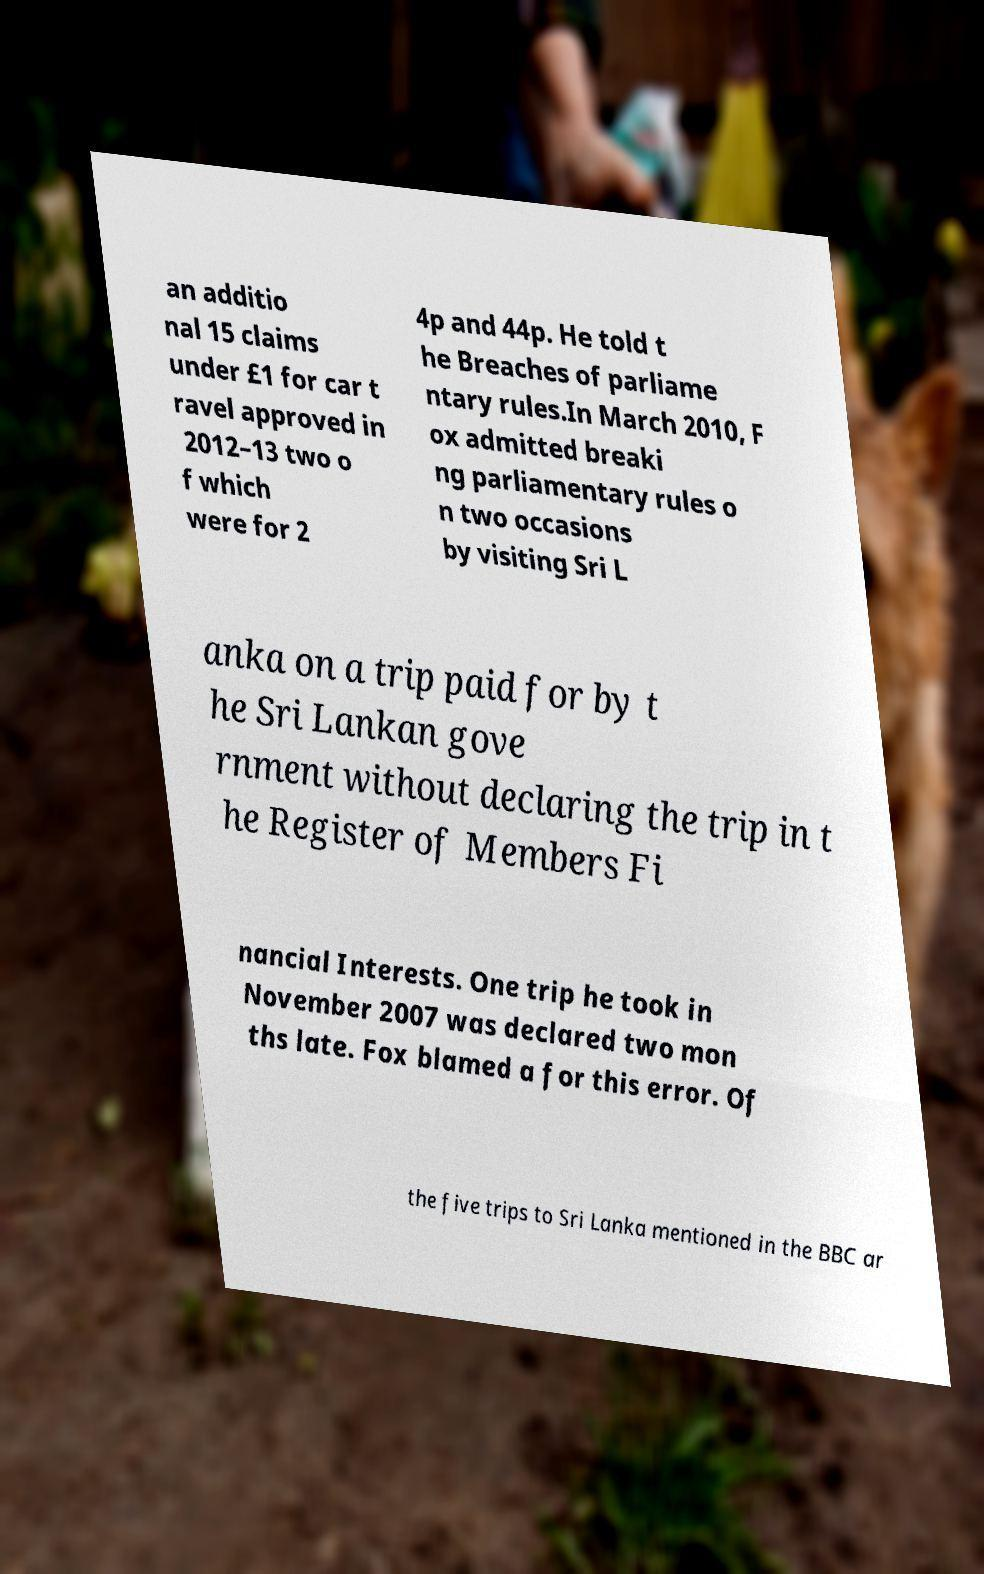Could you extract and type out the text from this image? an additio nal 15 claims under £1 for car t ravel approved in 2012–13 two o f which were for 2 4p and 44p. He told t he Breaches of parliame ntary rules.In March 2010, F ox admitted breaki ng parliamentary rules o n two occasions by visiting Sri L anka on a trip paid for by t he Sri Lankan gove rnment without declaring the trip in t he Register of Members Fi nancial Interests. One trip he took in November 2007 was declared two mon ths late. Fox blamed a for this error. Of the five trips to Sri Lanka mentioned in the BBC ar 